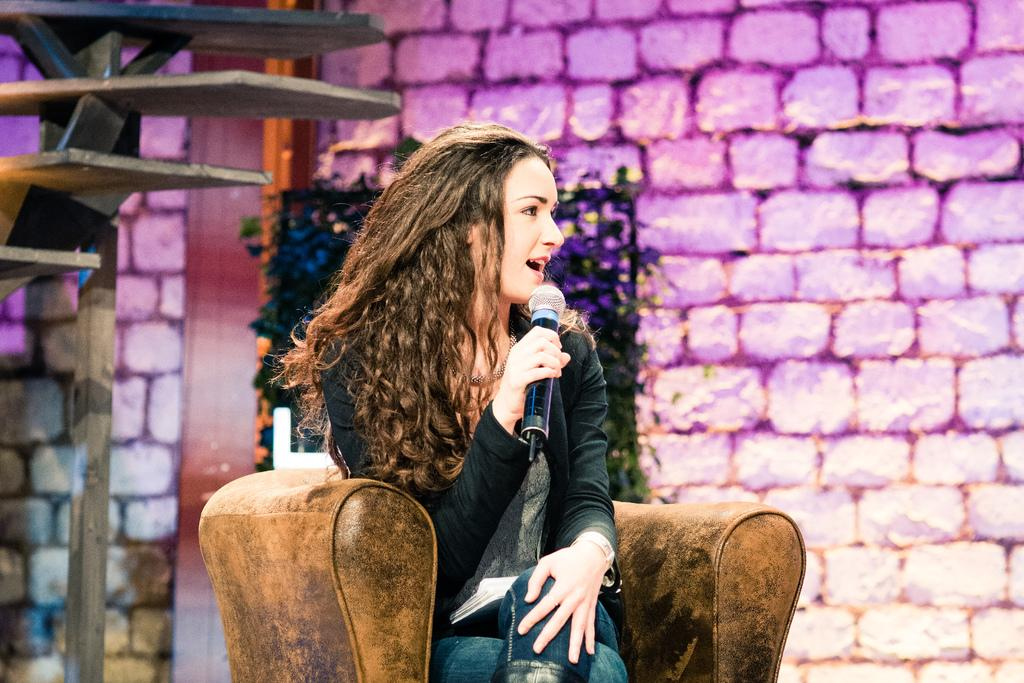What is the woman in the image doing? The woman is using a microphone in the image. Can you describe the woman's position in the image? The woman is seated on a chair in the image. What can be seen in the background of the image? There are wooden racks, plants, and a wall in the background of the image. What type of tin can be seen on the woman's pet in the image? There is no pet present in the image, and therefore no tin can be seen on it. 